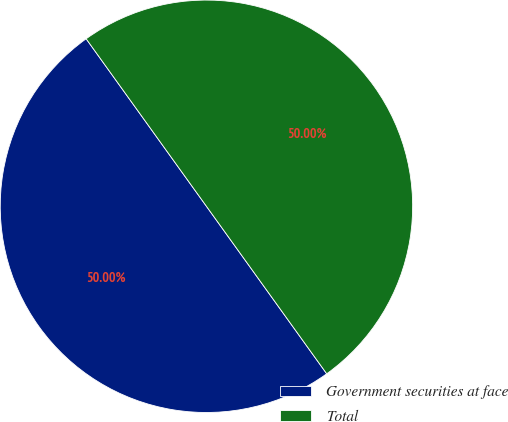Convert chart. <chart><loc_0><loc_0><loc_500><loc_500><pie_chart><fcel>Government securities at face<fcel>Total<nl><fcel>50.0%<fcel>50.0%<nl></chart> 